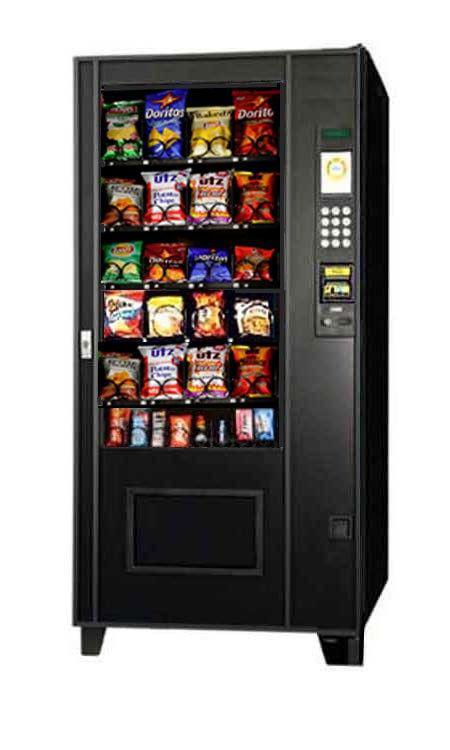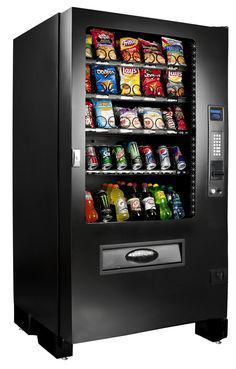The first image is the image on the left, the second image is the image on the right. Examine the images to the left and right. Is the description "The right image contains exactly one silver vending machine." accurate? Answer yes or no. No. The first image is the image on the left, the second image is the image on the right. Examine the images to the left and right. Is the description "At least one vending machine pictured is black with a footed base." accurate? Answer yes or no. Yes. 